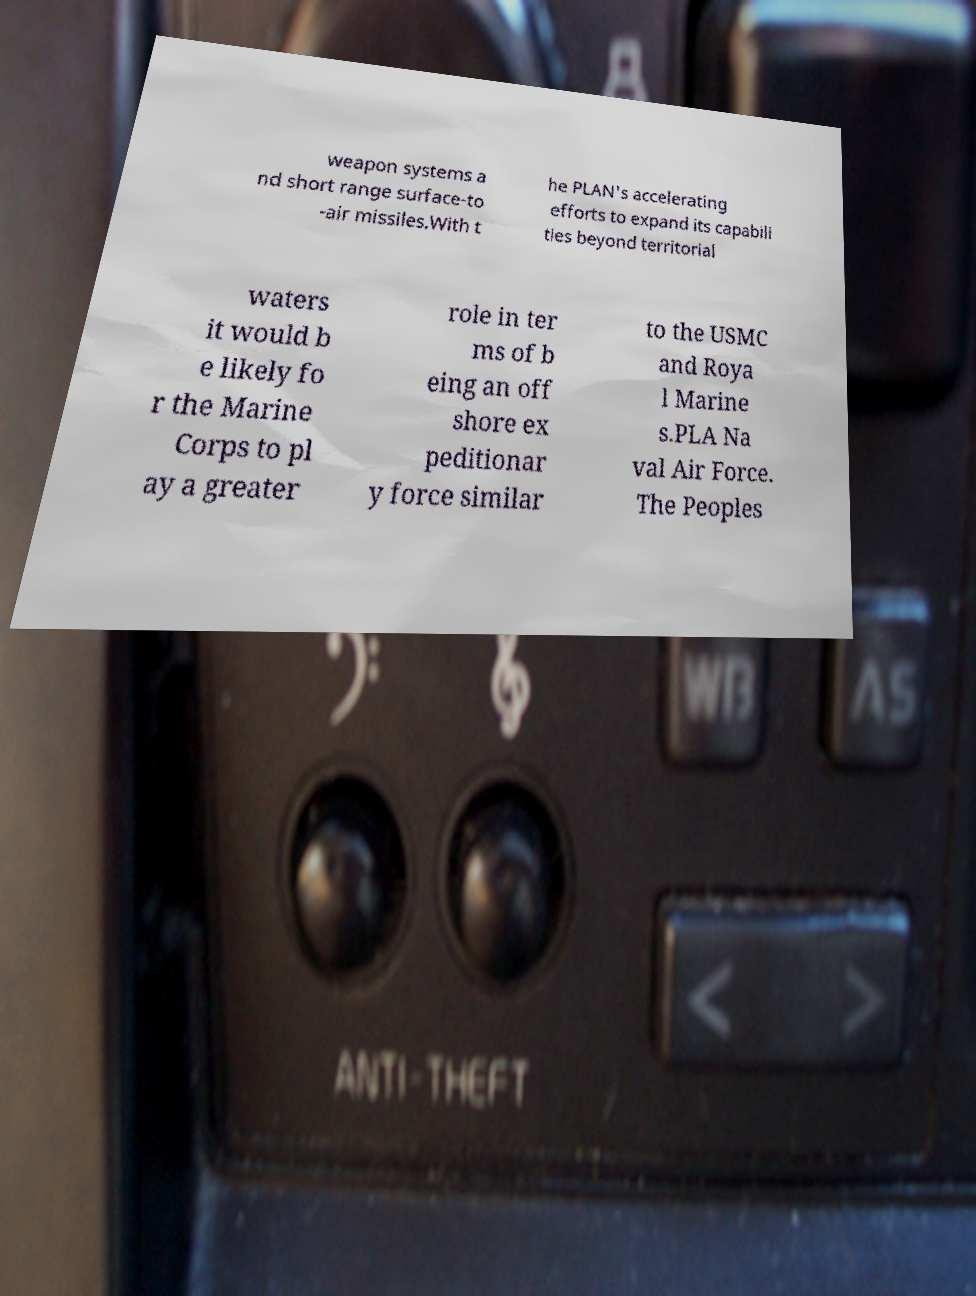Can you accurately transcribe the text from the provided image for me? weapon systems a nd short range surface-to -air missiles.With t he PLAN's accelerating efforts to expand its capabili ties beyond territorial waters it would b e likely fo r the Marine Corps to pl ay a greater role in ter ms of b eing an off shore ex peditionar y force similar to the USMC and Roya l Marine s.PLA Na val Air Force. The Peoples 